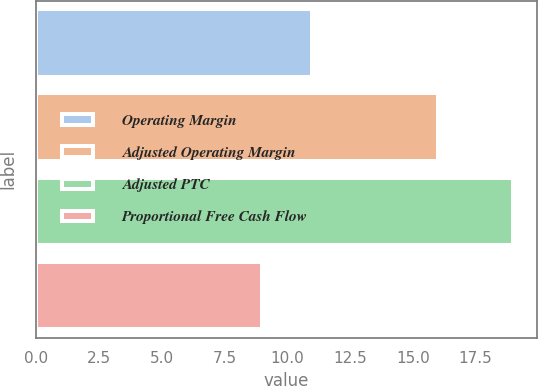<chart> <loc_0><loc_0><loc_500><loc_500><bar_chart><fcel>Operating Margin<fcel>Adjusted Operating Margin<fcel>Adjusted PTC<fcel>Proportional Free Cash Flow<nl><fcel>11<fcel>16<fcel>19<fcel>9<nl></chart> 